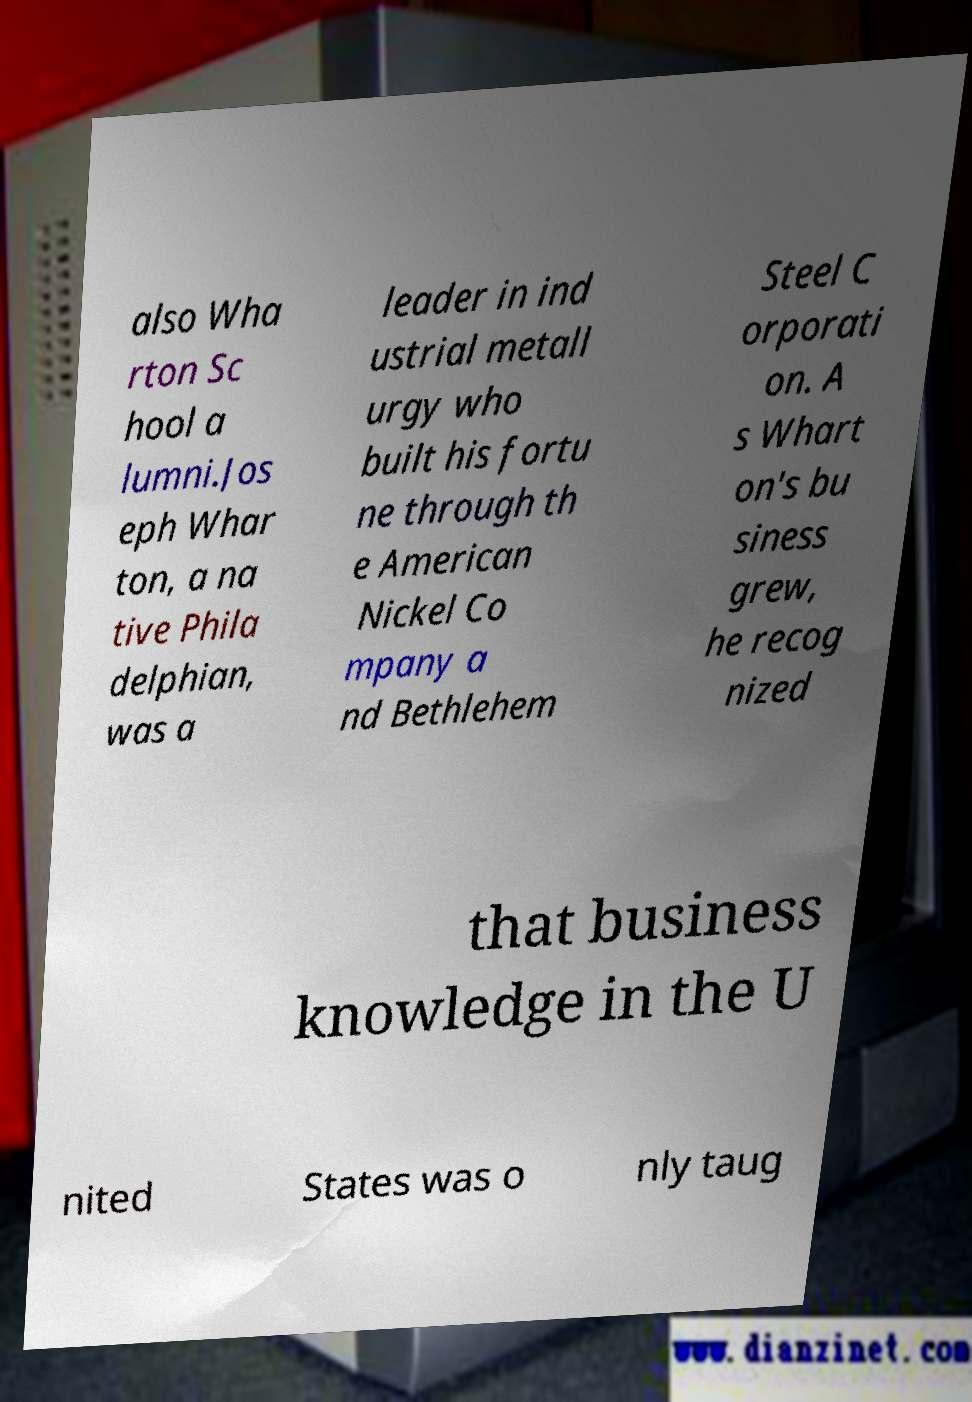I need the written content from this picture converted into text. Can you do that? also Wha rton Sc hool a lumni.Jos eph Whar ton, a na tive Phila delphian, was a leader in ind ustrial metall urgy who built his fortu ne through th e American Nickel Co mpany a nd Bethlehem Steel C orporati on. A s Whart on's bu siness grew, he recog nized that business knowledge in the U nited States was o nly taug 